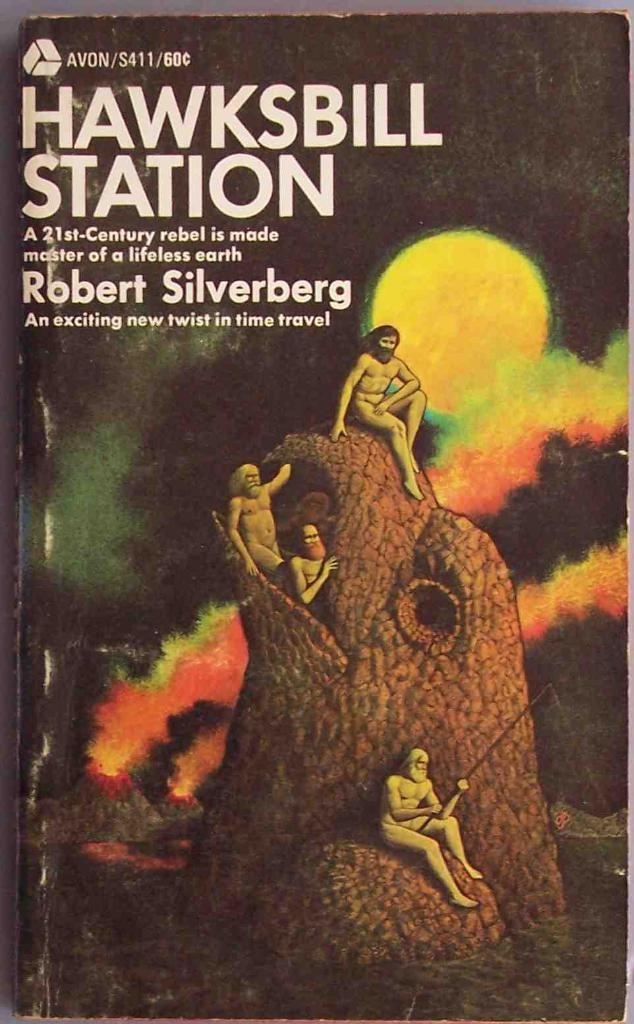<image>
Provide a brief description of the given image. a book cover written by robert silverberg with naked men sitting on a large tree fishing 